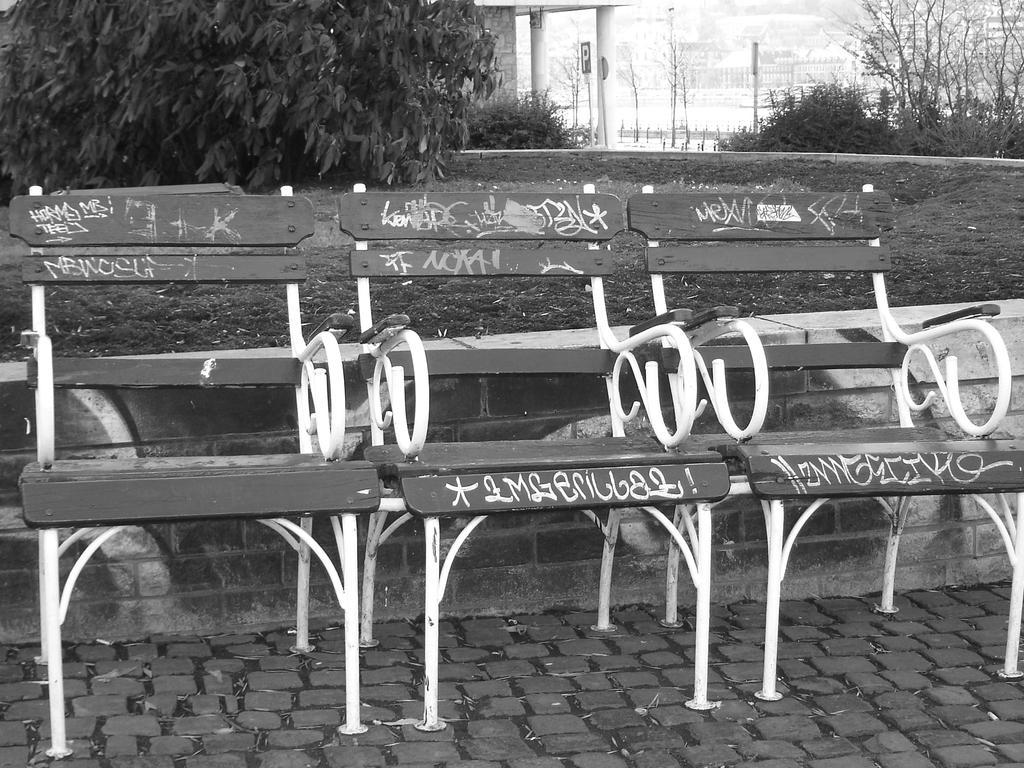Could you give a brief overview of what you see in this image? In this image I can see three chairs on the road. To the back of the choirs I can see the trees, board and the pillars of the building. In the back I can see few more trees and the railing. 